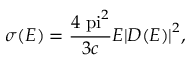Convert formula to latex. <formula><loc_0><loc_0><loc_500><loc_500>\sigma ( E ) = \frac { 4 \ p i ^ { 2 } } { 3 c } E { | D ( E ) | } ^ { 2 } ,</formula> 